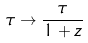<formula> <loc_0><loc_0><loc_500><loc_500>\tau \rightarrow \frac { \tau } { 1 + z }</formula> 